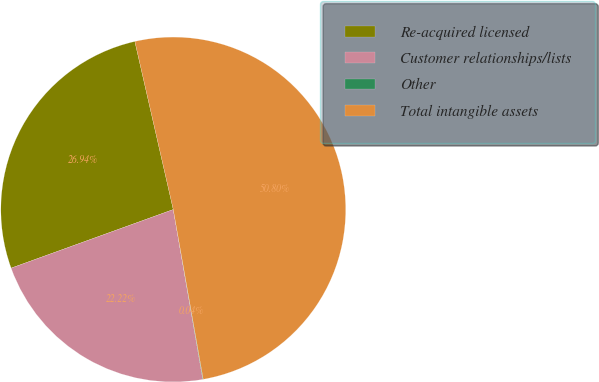Convert chart. <chart><loc_0><loc_0><loc_500><loc_500><pie_chart><fcel>Re-acquired licensed<fcel>Customer relationships/lists<fcel>Other<fcel>Total intangible assets<nl><fcel>26.94%<fcel>22.22%<fcel>0.04%<fcel>50.79%<nl></chart> 